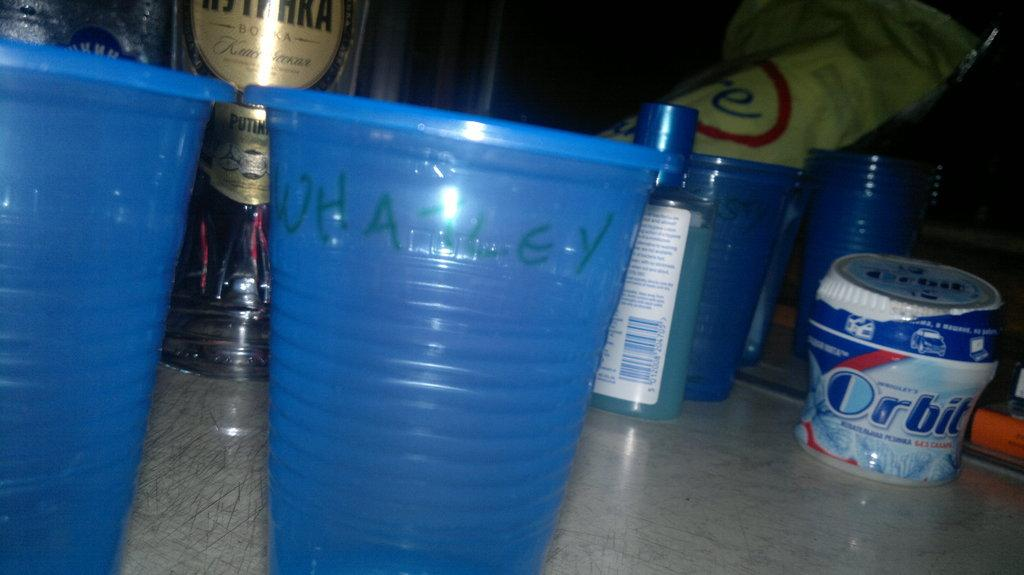Provide a one-sentence caption for the provided image. a persons collection of bar items and cups as well as a container of Orbit gum. 